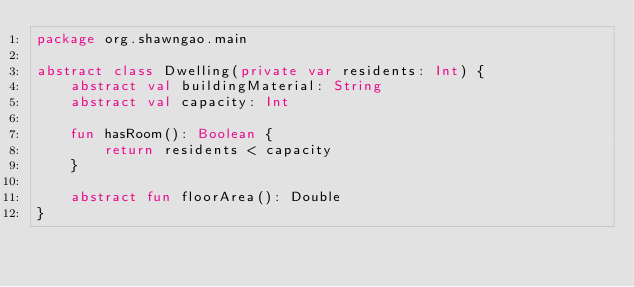<code> <loc_0><loc_0><loc_500><loc_500><_Kotlin_>package org.shawngao.main

abstract class Dwelling(private var residents: Int) {
    abstract val buildingMaterial: String
    abstract val capacity: Int

    fun hasRoom(): Boolean {
        return residents < capacity
    }

    abstract fun floorArea(): Double
}</code> 